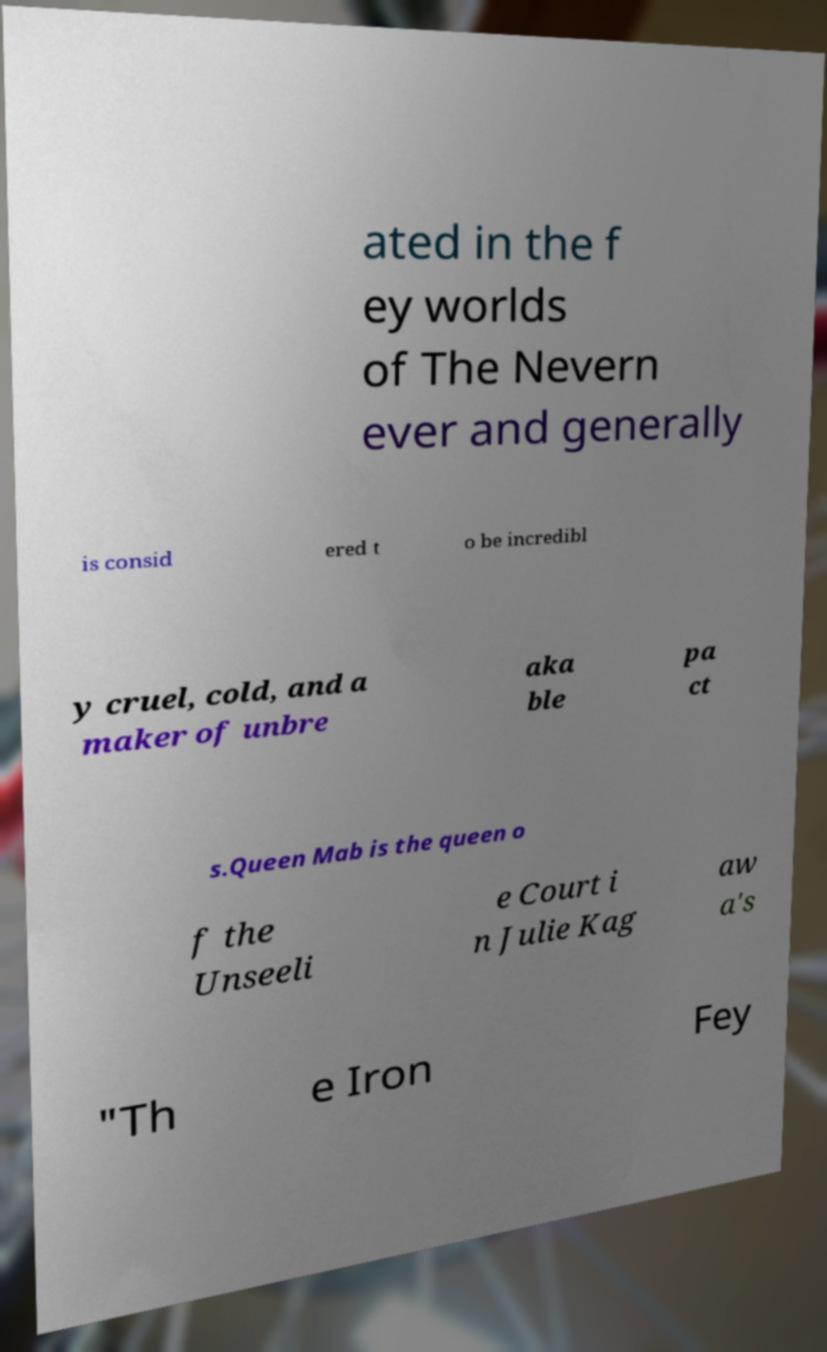I need the written content from this picture converted into text. Can you do that? ated in the f ey worlds of The Nevern ever and generally is consid ered t o be incredibl y cruel, cold, and a maker of unbre aka ble pa ct s.Queen Mab is the queen o f the Unseeli e Court i n Julie Kag aw a's "Th e Iron Fey 